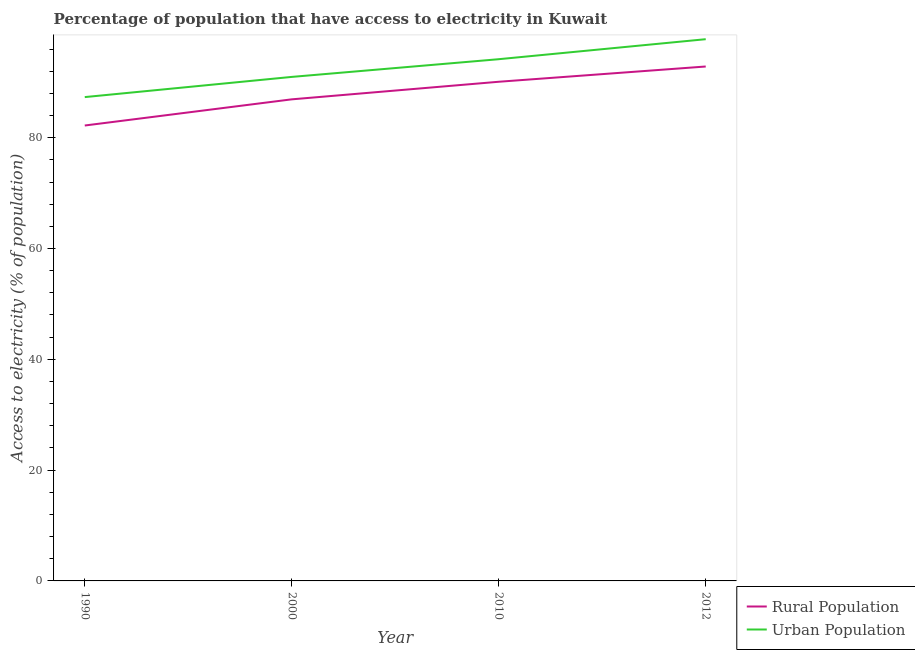How many different coloured lines are there?
Give a very brief answer. 2. Does the line corresponding to percentage of urban population having access to electricity intersect with the line corresponding to percentage of rural population having access to electricity?
Keep it short and to the point. No. Is the number of lines equal to the number of legend labels?
Make the answer very short. Yes. What is the percentage of rural population having access to electricity in 2000?
Offer a very short reply. 86.93. Across all years, what is the maximum percentage of rural population having access to electricity?
Keep it short and to the point. 92.85. Across all years, what is the minimum percentage of urban population having access to electricity?
Your answer should be very brief. 87.33. In which year was the percentage of urban population having access to electricity maximum?
Keep it short and to the point. 2012. What is the total percentage of rural population having access to electricity in the graph?
Provide a short and direct response. 352.08. What is the difference between the percentage of rural population having access to electricity in 1990 and that in 2000?
Your answer should be compact. -4.72. What is the difference between the percentage of urban population having access to electricity in 2010 and the percentage of rural population having access to electricity in 2012?
Provide a short and direct response. 1.32. What is the average percentage of urban population having access to electricity per year?
Provide a short and direct response. 92.57. In the year 2010, what is the difference between the percentage of urban population having access to electricity and percentage of rural population having access to electricity?
Your answer should be very brief. 4.07. What is the ratio of the percentage of rural population having access to electricity in 2010 to that in 2012?
Your response must be concise. 0.97. Is the percentage of rural population having access to electricity in 1990 less than that in 2010?
Keep it short and to the point. Yes. Is the difference between the percentage of urban population having access to electricity in 1990 and 2010 greater than the difference between the percentage of rural population having access to electricity in 1990 and 2010?
Your response must be concise. Yes. What is the difference between the highest and the second highest percentage of urban population having access to electricity?
Ensure brevity in your answer.  3.61. What is the difference between the highest and the lowest percentage of rural population having access to electricity?
Ensure brevity in your answer.  10.65. In how many years, is the percentage of urban population having access to electricity greater than the average percentage of urban population having access to electricity taken over all years?
Give a very brief answer. 2. Does the percentage of rural population having access to electricity monotonically increase over the years?
Give a very brief answer. Yes. Is the percentage of urban population having access to electricity strictly greater than the percentage of rural population having access to electricity over the years?
Give a very brief answer. Yes. Is the percentage of urban population having access to electricity strictly less than the percentage of rural population having access to electricity over the years?
Keep it short and to the point. No. How many years are there in the graph?
Ensure brevity in your answer.  4. Does the graph contain any zero values?
Ensure brevity in your answer.  No. Does the graph contain grids?
Your answer should be compact. No. Where does the legend appear in the graph?
Your answer should be compact. Bottom right. How many legend labels are there?
Provide a succinct answer. 2. What is the title of the graph?
Your answer should be compact. Percentage of population that have access to electricity in Kuwait. Does "Females" appear as one of the legend labels in the graph?
Your response must be concise. No. What is the label or title of the Y-axis?
Give a very brief answer. Access to electricity (% of population). What is the Access to electricity (% of population) in Rural Population in 1990?
Offer a very short reply. 82.2. What is the Access to electricity (% of population) in Urban Population in 1990?
Offer a terse response. 87.33. What is the Access to electricity (% of population) in Rural Population in 2000?
Keep it short and to the point. 86.93. What is the Access to electricity (% of population) in Urban Population in 2000?
Offer a very short reply. 90.98. What is the Access to electricity (% of population) in Rural Population in 2010?
Your answer should be very brief. 90.1. What is the Access to electricity (% of population) in Urban Population in 2010?
Provide a short and direct response. 94.17. What is the Access to electricity (% of population) of Rural Population in 2012?
Make the answer very short. 92.85. What is the Access to electricity (% of population) in Urban Population in 2012?
Keep it short and to the point. 97.78. Across all years, what is the maximum Access to electricity (% of population) in Rural Population?
Make the answer very short. 92.85. Across all years, what is the maximum Access to electricity (% of population) of Urban Population?
Give a very brief answer. 97.78. Across all years, what is the minimum Access to electricity (% of population) in Rural Population?
Offer a very short reply. 82.2. Across all years, what is the minimum Access to electricity (% of population) in Urban Population?
Offer a terse response. 87.33. What is the total Access to electricity (% of population) of Rural Population in the graph?
Provide a short and direct response. 352.08. What is the total Access to electricity (% of population) of Urban Population in the graph?
Keep it short and to the point. 370.26. What is the difference between the Access to electricity (% of population) in Rural Population in 1990 and that in 2000?
Offer a very short reply. -4.72. What is the difference between the Access to electricity (% of population) in Urban Population in 1990 and that in 2000?
Your answer should be compact. -3.64. What is the difference between the Access to electricity (% of population) in Rural Population in 1990 and that in 2010?
Make the answer very short. -7.9. What is the difference between the Access to electricity (% of population) of Urban Population in 1990 and that in 2010?
Keep it short and to the point. -6.84. What is the difference between the Access to electricity (% of population) of Rural Population in 1990 and that in 2012?
Your answer should be very brief. -10.65. What is the difference between the Access to electricity (% of population) of Urban Population in 1990 and that in 2012?
Your response must be concise. -10.45. What is the difference between the Access to electricity (% of population) in Rural Population in 2000 and that in 2010?
Give a very brief answer. -3.17. What is the difference between the Access to electricity (% of population) in Urban Population in 2000 and that in 2010?
Your answer should be very brief. -3.2. What is the difference between the Access to electricity (% of population) of Rural Population in 2000 and that in 2012?
Offer a very short reply. -5.93. What is the difference between the Access to electricity (% of population) of Urban Population in 2000 and that in 2012?
Offer a very short reply. -6.81. What is the difference between the Access to electricity (% of population) in Rural Population in 2010 and that in 2012?
Ensure brevity in your answer.  -2.75. What is the difference between the Access to electricity (% of population) of Urban Population in 2010 and that in 2012?
Your answer should be very brief. -3.61. What is the difference between the Access to electricity (% of population) of Rural Population in 1990 and the Access to electricity (% of population) of Urban Population in 2000?
Your answer should be compact. -8.77. What is the difference between the Access to electricity (% of population) in Rural Population in 1990 and the Access to electricity (% of population) in Urban Population in 2010?
Offer a terse response. -11.97. What is the difference between the Access to electricity (% of population) of Rural Population in 1990 and the Access to electricity (% of population) of Urban Population in 2012?
Give a very brief answer. -15.58. What is the difference between the Access to electricity (% of population) in Rural Population in 2000 and the Access to electricity (% of population) in Urban Population in 2010?
Your response must be concise. -7.25. What is the difference between the Access to electricity (% of population) in Rural Population in 2000 and the Access to electricity (% of population) in Urban Population in 2012?
Provide a short and direct response. -10.86. What is the difference between the Access to electricity (% of population) of Rural Population in 2010 and the Access to electricity (% of population) of Urban Population in 2012?
Ensure brevity in your answer.  -7.68. What is the average Access to electricity (% of population) of Rural Population per year?
Give a very brief answer. 88.02. What is the average Access to electricity (% of population) in Urban Population per year?
Provide a short and direct response. 92.57. In the year 1990, what is the difference between the Access to electricity (% of population) of Rural Population and Access to electricity (% of population) of Urban Population?
Give a very brief answer. -5.13. In the year 2000, what is the difference between the Access to electricity (% of population) in Rural Population and Access to electricity (% of population) in Urban Population?
Your answer should be compact. -4.05. In the year 2010, what is the difference between the Access to electricity (% of population) of Rural Population and Access to electricity (% of population) of Urban Population?
Make the answer very short. -4.07. In the year 2012, what is the difference between the Access to electricity (% of population) in Rural Population and Access to electricity (% of population) in Urban Population?
Provide a short and direct response. -4.93. What is the ratio of the Access to electricity (% of population) in Rural Population in 1990 to that in 2000?
Provide a short and direct response. 0.95. What is the ratio of the Access to electricity (% of population) of Urban Population in 1990 to that in 2000?
Keep it short and to the point. 0.96. What is the ratio of the Access to electricity (% of population) of Rural Population in 1990 to that in 2010?
Give a very brief answer. 0.91. What is the ratio of the Access to electricity (% of population) of Urban Population in 1990 to that in 2010?
Your response must be concise. 0.93. What is the ratio of the Access to electricity (% of population) in Rural Population in 1990 to that in 2012?
Your response must be concise. 0.89. What is the ratio of the Access to electricity (% of population) in Urban Population in 1990 to that in 2012?
Ensure brevity in your answer.  0.89. What is the ratio of the Access to electricity (% of population) of Rural Population in 2000 to that in 2010?
Keep it short and to the point. 0.96. What is the ratio of the Access to electricity (% of population) in Urban Population in 2000 to that in 2010?
Make the answer very short. 0.97. What is the ratio of the Access to electricity (% of population) in Rural Population in 2000 to that in 2012?
Ensure brevity in your answer.  0.94. What is the ratio of the Access to electricity (% of population) of Urban Population in 2000 to that in 2012?
Offer a very short reply. 0.93. What is the ratio of the Access to electricity (% of population) of Rural Population in 2010 to that in 2012?
Keep it short and to the point. 0.97. What is the ratio of the Access to electricity (% of population) of Urban Population in 2010 to that in 2012?
Your response must be concise. 0.96. What is the difference between the highest and the second highest Access to electricity (% of population) in Rural Population?
Provide a succinct answer. 2.75. What is the difference between the highest and the second highest Access to electricity (% of population) of Urban Population?
Your response must be concise. 3.61. What is the difference between the highest and the lowest Access to electricity (% of population) in Rural Population?
Offer a terse response. 10.65. What is the difference between the highest and the lowest Access to electricity (% of population) in Urban Population?
Your response must be concise. 10.45. 